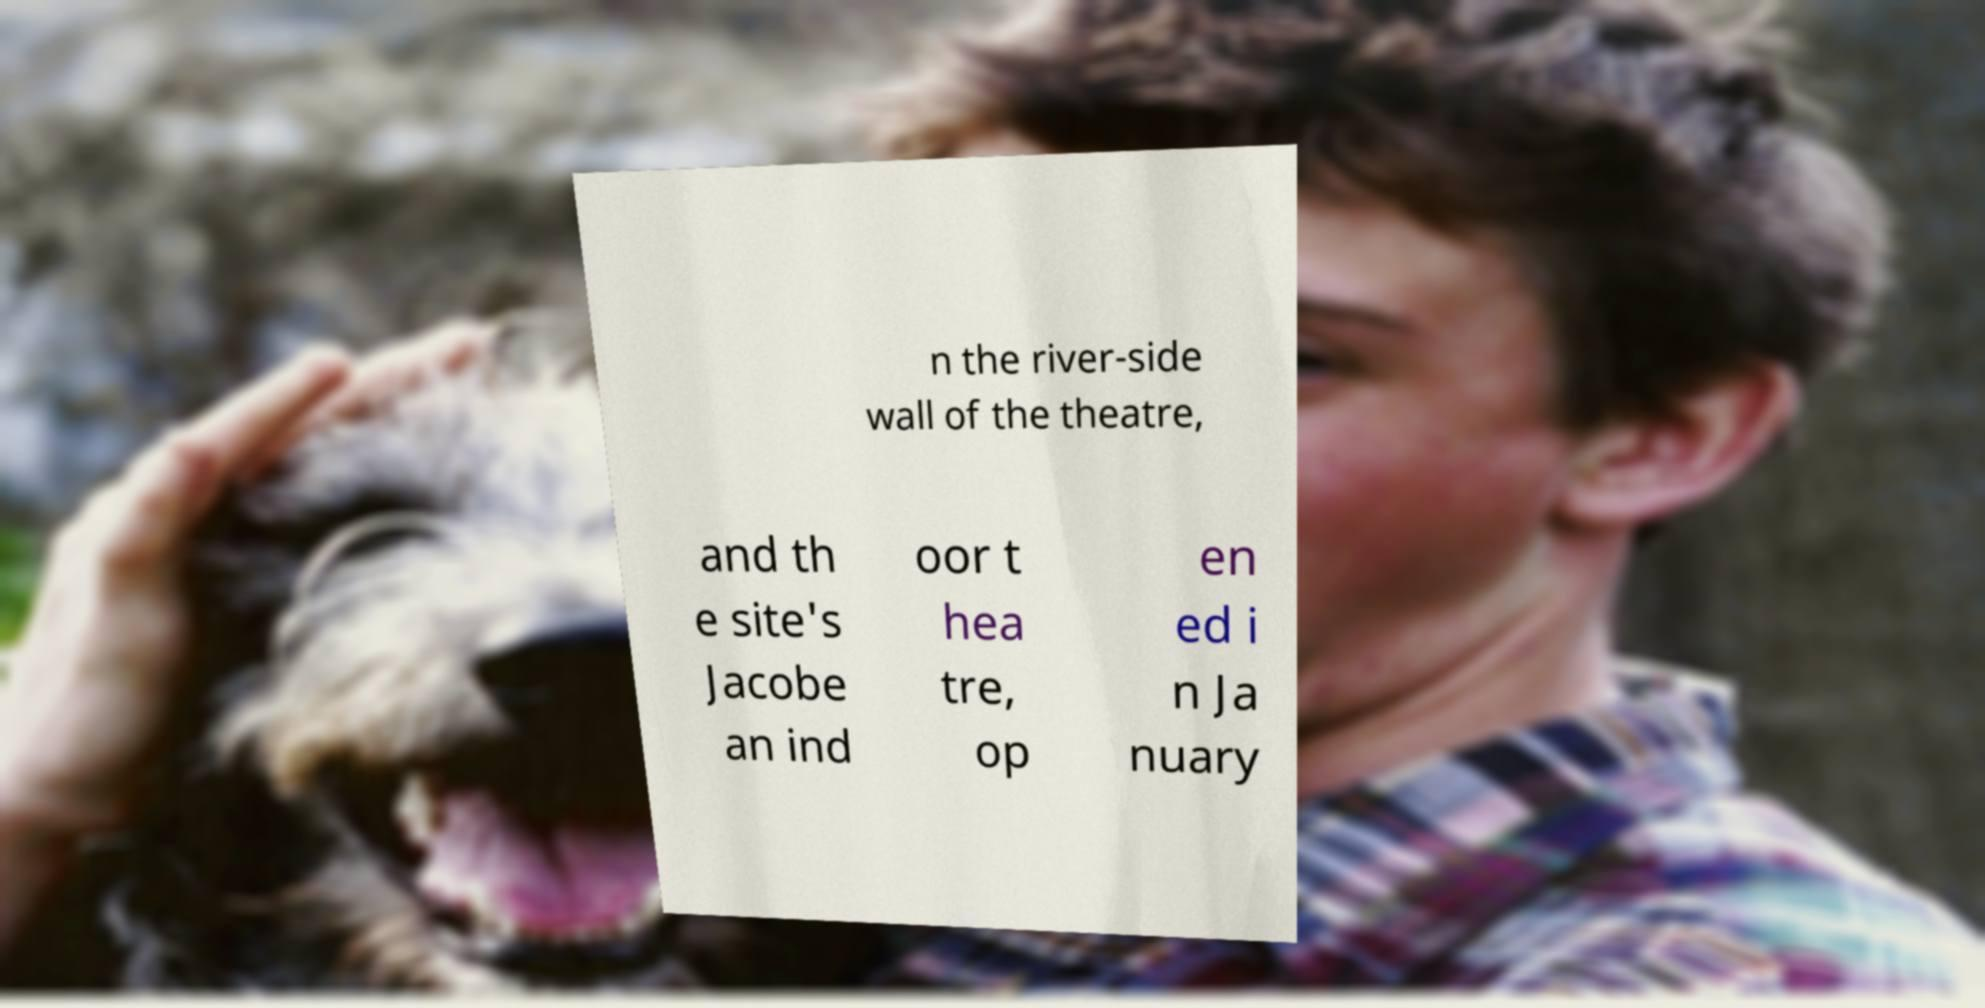Could you assist in decoding the text presented in this image and type it out clearly? n the river-side wall of the theatre, and th e site's Jacobe an ind oor t hea tre, op en ed i n Ja nuary 